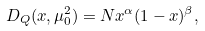Convert formula to latex. <formula><loc_0><loc_0><loc_500><loc_500>D _ { Q } ( x , \mu _ { 0 } ^ { 2 } ) = N x ^ { \alpha } ( 1 - x ) ^ { \beta } ,</formula> 